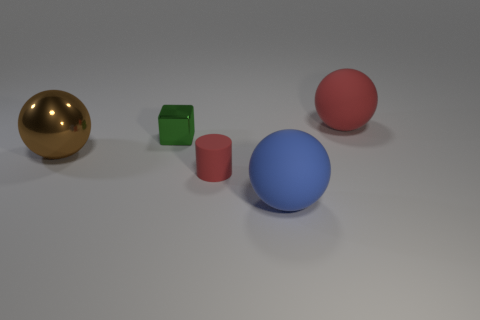Subtract all brown blocks. Subtract all cyan cylinders. How many blocks are left? 1 Add 3 large gray cubes. How many objects exist? 8 Subtract all blocks. How many objects are left? 4 Add 4 small red things. How many small red things exist? 5 Subtract 1 red balls. How many objects are left? 4 Subtract all blue objects. Subtract all blocks. How many objects are left? 3 Add 3 red matte cylinders. How many red matte cylinders are left? 4 